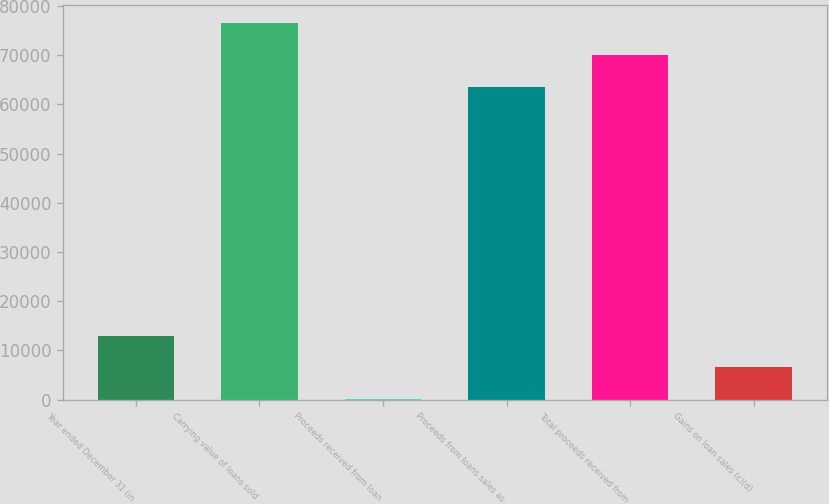<chart> <loc_0><loc_0><loc_500><loc_500><bar_chart><fcel>Year ended December 31 (in<fcel>Carrying value of loans sold<fcel>Proceeds received from loan<fcel>Proceeds from loans sales as<fcel>Total proceeds received from<fcel>Gains on loan sales (c)(d)<nl><fcel>13002<fcel>76427<fcel>117<fcel>63542<fcel>69984.5<fcel>6559.5<nl></chart> 